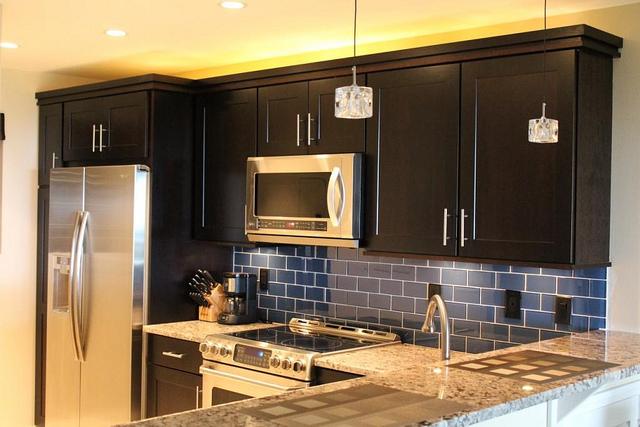What is the countertop made from?
Keep it brief. Granite. Is the fridge full?
Give a very brief answer. Yes. What is that kind of tile treatment called?
Answer briefly. Brick. What shape is the light on the ceiling?
Write a very short answer. Round. Are these three doors?
Answer briefly. No. 